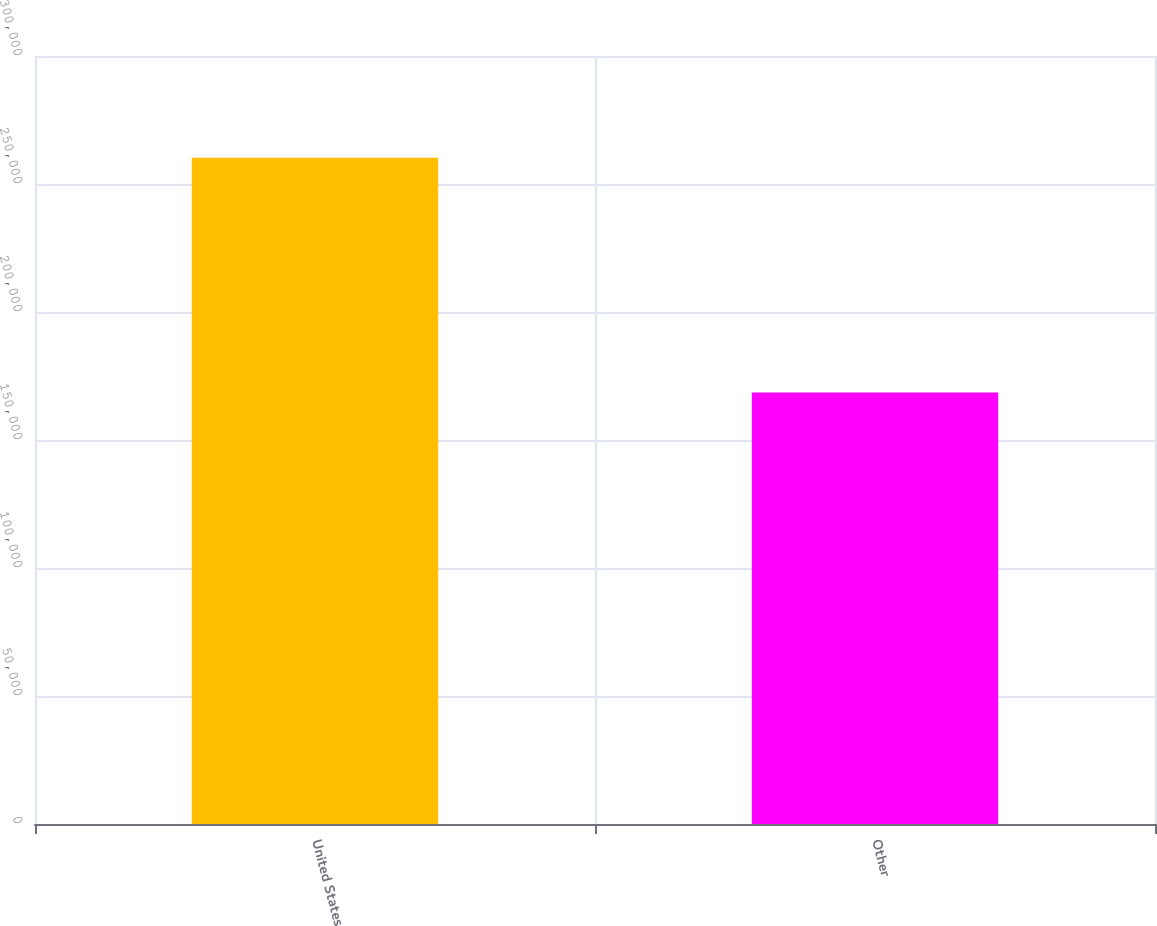Convert chart to OTSL. <chart><loc_0><loc_0><loc_500><loc_500><bar_chart><fcel>United States<fcel>Other<nl><fcel>260247<fcel>168569<nl></chart> 